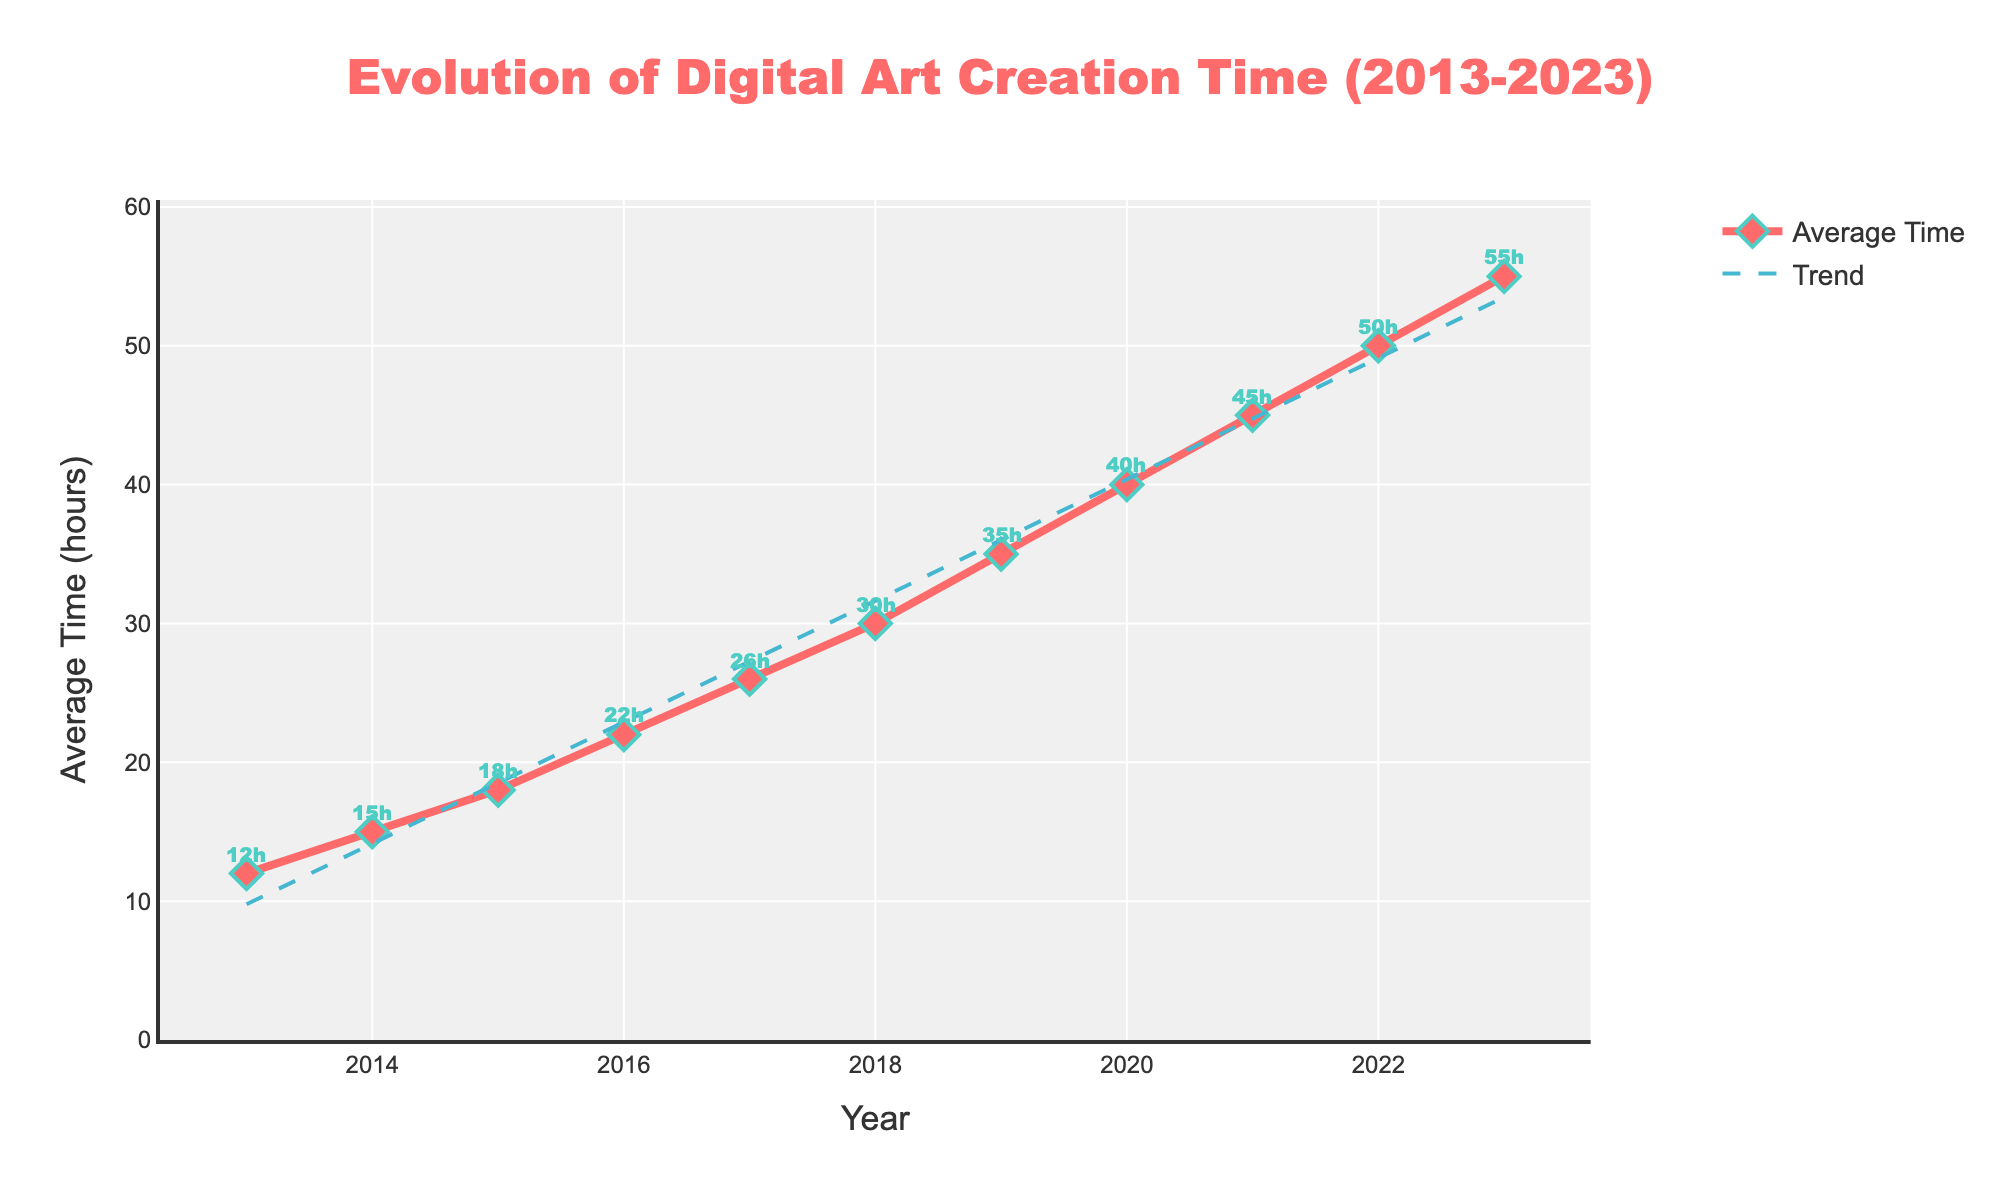What's the overall trend in the average time spent on digital art creation from 2013 to 2023? The line chart shows a consistent upward trend from 2013 to 2023, indicating that the average time spent on digital art creation has been increasing each year
Answer: Increasing How much did the average time spent on digital art creation change from 2016 to 2023? In 2016, the average time was 22 hours, and in 2023, it was 55 hours. The change is 55 - 22 = 33 hours
Answer: 33 hours In which year did the average time spent on digital art creation surpass 30 hours? The average time surpassed 30 hours in 2018, as indicated by the point marking 30 hours
Answer: 2018 What is the color of the trend line? The trend line is denoted by a dashed cyan line in the figure
Answer: Cyan Calculate the average annual increase in time spent on digital art creation over the decade. The increase from 2013 to 2023 is 55 - 12 = 43 hours. There are 10 years in this period, so the average annual increase is 43/10 = 4.3 hours per year
Answer: 4.3 hours per year By how many hours did the average time increase from 2017 to 2019? From the chart, the average time in 2017 was 26 hours, and in 2019 it was 35 hours. The increase is 35 - 26 = 9 hours
Answer: 9 hours What was the average time spent on digital art creation in 2020 and how does it compare to 2022? In 2020, the average time was 40 hours, and in 2022 it was 50 hours. This shows a 10-hour increase from 2020 to 2022
Answer: 10-hour increase Estimate the slope of the trend line indicating the change in average time over the decade. The slope of the trend line can be estimated by finding the change in y (time) over the change in x (year). From 2013 to 2023, the change in time is 43 hours over 10 years, so the slope is approximately 4.3
Answer: 4.3 Identify the year with the highest average time spent on digital art creation and specify the time. The year with the highest average time is 2023 with an average time of 55 hours
Answer: 2023, 55 hours 